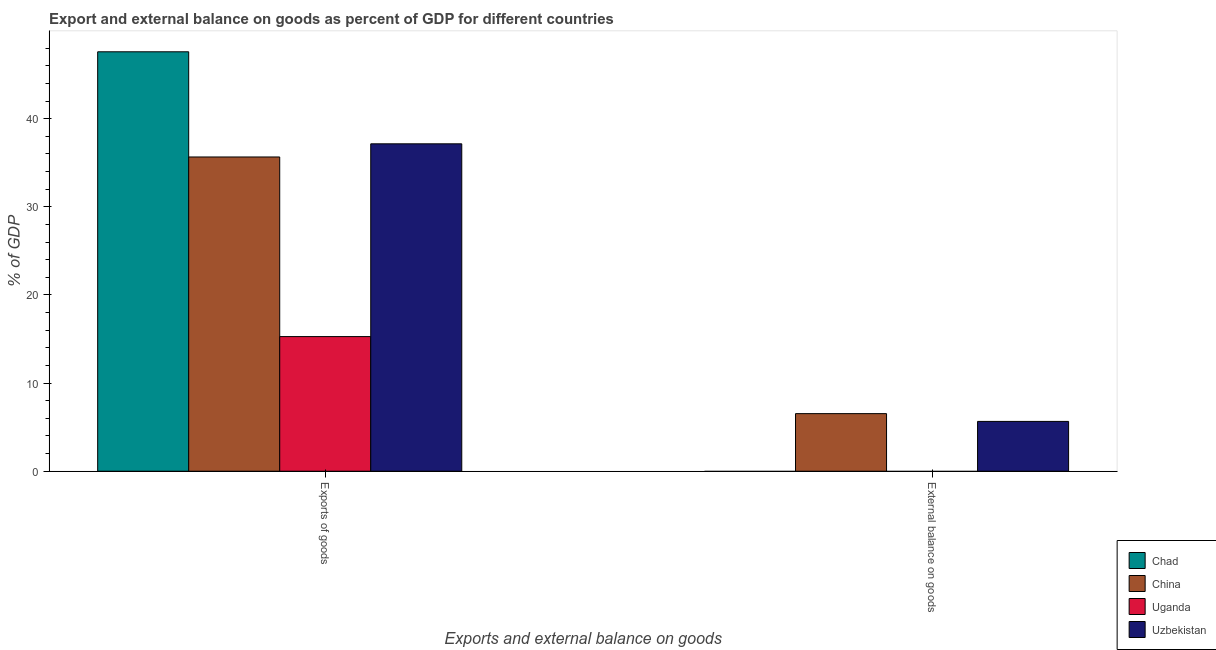How many groups of bars are there?
Offer a terse response. 2. What is the label of the 2nd group of bars from the left?
Your answer should be compact. External balance on goods. What is the export of goods as percentage of gdp in Chad?
Your answer should be very brief. 47.58. Across all countries, what is the maximum export of goods as percentage of gdp?
Make the answer very short. 47.58. Across all countries, what is the minimum external balance on goods as percentage of gdp?
Offer a very short reply. 0. In which country was the external balance on goods as percentage of gdp maximum?
Give a very brief answer. China. What is the total external balance on goods as percentage of gdp in the graph?
Give a very brief answer. 12.19. What is the difference between the export of goods as percentage of gdp in Chad and that in China?
Offer a terse response. 11.93. What is the difference between the external balance on goods as percentage of gdp in China and the export of goods as percentage of gdp in Uzbekistan?
Ensure brevity in your answer.  -30.61. What is the average export of goods as percentage of gdp per country?
Your answer should be very brief. 33.91. What is the difference between the external balance on goods as percentage of gdp and export of goods as percentage of gdp in China?
Make the answer very short. -29.12. In how many countries, is the export of goods as percentage of gdp greater than 22 %?
Keep it short and to the point. 3. What is the ratio of the export of goods as percentage of gdp in Uzbekistan to that in Uganda?
Ensure brevity in your answer.  2.43. Are all the bars in the graph horizontal?
Offer a very short reply. No. How many countries are there in the graph?
Ensure brevity in your answer.  4. What is the difference between two consecutive major ticks on the Y-axis?
Your answer should be very brief. 10. Are the values on the major ticks of Y-axis written in scientific E-notation?
Provide a short and direct response. No. Does the graph contain grids?
Offer a terse response. No. How many legend labels are there?
Keep it short and to the point. 4. How are the legend labels stacked?
Keep it short and to the point. Vertical. What is the title of the graph?
Your answer should be very brief. Export and external balance on goods as percent of GDP for different countries. Does "Korea (Democratic)" appear as one of the legend labels in the graph?
Provide a succinct answer. No. What is the label or title of the X-axis?
Provide a short and direct response. Exports and external balance on goods. What is the label or title of the Y-axis?
Keep it short and to the point. % of GDP. What is the % of GDP in Chad in Exports of goods?
Offer a very short reply. 47.58. What is the % of GDP in China in Exports of goods?
Your answer should be compact. 35.65. What is the % of GDP of Uganda in Exports of goods?
Provide a succinct answer. 15.28. What is the % of GDP in Uzbekistan in Exports of goods?
Offer a very short reply. 37.14. What is the % of GDP in Chad in External balance on goods?
Offer a terse response. 0. What is the % of GDP in China in External balance on goods?
Your response must be concise. 6.53. What is the % of GDP in Uzbekistan in External balance on goods?
Your response must be concise. 5.65. Across all Exports and external balance on goods, what is the maximum % of GDP in Chad?
Provide a short and direct response. 47.58. Across all Exports and external balance on goods, what is the maximum % of GDP in China?
Your answer should be very brief. 35.65. Across all Exports and external balance on goods, what is the maximum % of GDP in Uganda?
Your answer should be very brief. 15.28. Across all Exports and external balance on goods, what is the maximum % of GDP in Uzbekistan?
Provide a succinct answer. 37.14. Across all Exports and external balance on goods, what is the minimum % of GDP in China?
Make the answer very short. 6.53. Across all Exports and external balance on goods, what is the minimum % of GDP in Uzbekistan?
Your answer should be very brief. 5.65. What is the total % of GDP of Chad in the graph?
Your response must be concise. 47.58. What is the total % of GDP in China in the graph?
Your answer should be very brief. 42.19. What is the total % of GDP of Uganda in the graph?
Keep it short and to the point. 15.28. What is the total % of GDP in Uzbekistan in the graph?
Provide a short and direct response. 42.8. What is the difference between the % of GDP in China in Exports of goods and that in External balance on goods?
Provide a succinct answer. 29.12. What is the difference between the % of GDP of Uzbekistan in Exports of goods and that in External balance on goods?
Make the answer very short. 31.49. What is the difference between the % of GDP of Chad in Exports of goods and the % of GDP of China in External balance on goods?
Offer a terse response. 41.05. What is the difference between the % of GDP in Chad in Exports of goods and the % of GDP in Uzbekistan in External balance on goods?
Provide a short and direct response. 41.93. What is the difference between the % of GDP of China in Exports of goods and the % of GDP of Uzbekistan in External balance on goods?
Offer a very short reply. 30. What is the difference between the % of GDP of Uganda in Exports of goods and the % of GDP of Uzbekistan in External balance on goods?
Ensure brevity in your answer.  9.62. What is the average % of GDP in Chad per Exports and external balance on goods?
Ensure brevity in your answer.  23.79. What is the average % of GDP in China per Exports and external balance on goods?
Ensure brevity in your answer.  21.09. What is the average % of GDP of Uganda per Exports and external balance on goods?
Your answer should be compact. 7.64. What is the average % of GDP in Uzbekistan per Exports and external balance on goods?
Your answer should be very brief. 21.4. What is the difference between the % of GDP in Chad and % of GDP in China in Exports of goods?
Your answer should be compact. 11.93. What is the difference between the % of GDP in Chad and % of GDP in Uganda in Exports of goods?
Keep it short and to the point. 32.31. What is the difference between the % of GDP of Chad and % of GDP of Uzbekistan in Exports of goods?
Make the answer very short. 10.44. What is the difference between the % of GDP in China and % of GDP in Uganda in Exports of goods?
Give a very brief answer. 20.38. What is the difference between the % of GDP of China and % of GDP of Uzbekistan in Exports of goods?
Give a very brief answer. -1.49. What is the difference between the % of GDP of Uganda and % of GDP of Uzbekistan in Exports of goods?
Give a very brief answer. -21.87. What is the difference between the % of GDP in China and % of GDP in Uzbekistan in External balance on goods?
Keep it short and to the point. 0.88. What is the ratio of the % of GDP of China in Exports of goods to that in External balance on goods?
Provide a succinct answer. 5.46. What is the ratio of the % of GDP in Uzbekistan in Exports of goods to that in External balance on goods?
Offer a very short reply. 6.57. What is the difference between the highest and the second highest % of GDP in China?
Your answer should be very brief. 29.12. What is the difference between the highest and the second highest % of GDP of Uzbekistan?
Make the answer very short. 31.49. What is the difference between the highest and the lowest % of GDP in Chad?
Make the answer very short. 47.58. What is the difference between the highest and the lowest % of GDP in China?
Ensure brevity in your answer.  29.12. What is the difference between the highest and the lowest % of GDP in Uganda?
Offer a very short reply. 15.28. What is the difference between the highest and the lowest % of GDP of Uzbekistan?
Your answer should be very brief. 31.49. 